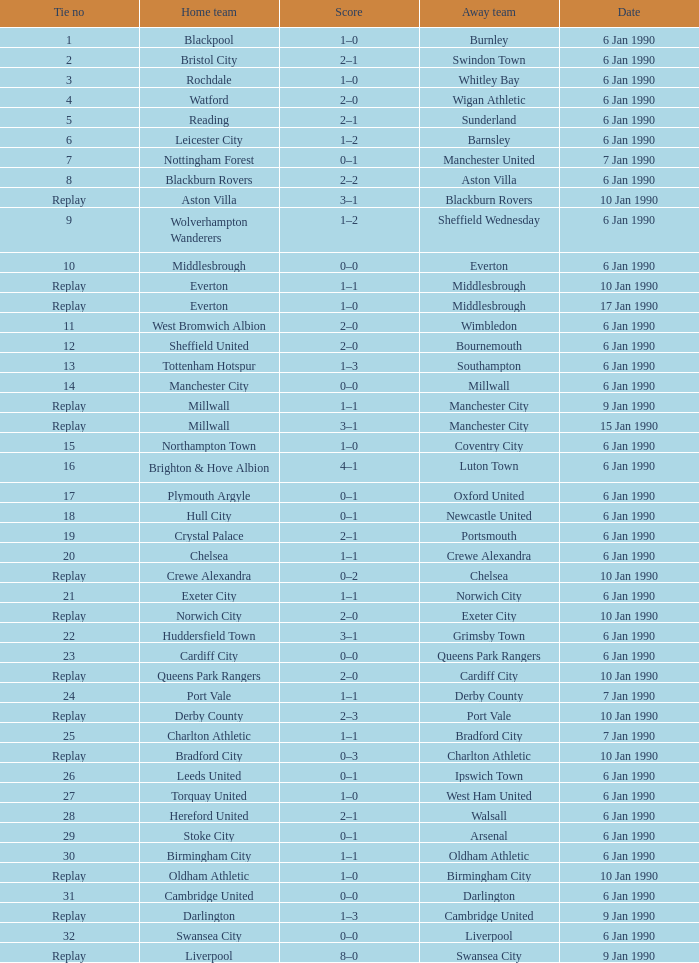Can you parse all the data within this table? {'header': ['Tie no', 'Home team', 'Score', 'Away team', 'Date'], 'rows': [['1', 'Blackpool', '1–0', 'Burnley', '6 Jan 1990'], ['2', 'Bristol City', '2–1', 'Swindon Town', '6 Jan 1990'], ['3', 'Rochdale', '1–0', 'Whitley Bay', '6 Jan 1990'], ['4', 'Watford', '2–0', 'Wigan Athletic', '6 Jan 1990'], ['5', 'Reading', '2–1', 'Sunderland', '6 Jan 1990'], ['6', 'Leicester City', '1–2', 'Barnsley', '6 Jan 1990'], ['7', 'Nottingham Forest', '0–1', 'Manchester United', '7 Jan 1990'], ['8', 'Blackburn Rovers', '2–2', 'Aston Villa', '6 Jan 1990'], ['Replay', 'Aston Villa', '3–1', 'Blackburn Rovers', '10 Jan 1990'], ['9', 'Wolverhampton Wanderers', '1–2', 'Sheffield Wednesday', '6 Jan 1990'], ['10', 'Middlesbrough', '0–0', 'Everton', '6 Jan 1990'], ['Replay', 'Everton', '1–1', 'Middlesbrough', '10 Jan 1990'], ['Replay', 'Everton', '1–0', 'Middlesbrough', '17 Jan 1990'], ['11', 'West Bromwich Albion', '2–0', 'Wimbledon', '6 Jan 1990'], ['12', 'Sheffield United', '2–0', 'Bournemouth', '6 Jan 1990'], ['13', 'Tottenham Hotspur', '1–3', 'Southampton', '6 Jan 1990'], ['14', 'Manchester City', '0–0', 'Millwall', '6 Jan 1990'], ['Replay', 'Millwall', '1–1', 'Manchester City', '9 Jan 1990'], ['Replay', 'Millwall', '3–1', 'Manchester City', '15 Jan 1990'], ['15', 'Northampton Town', '1–0', 'Coventry City', '6 Jan 1990'], ['16', 'Brighton & Hove Albion', '4–1', 'Luton Town', '6 Jan 1990'], ['17', 'Plymouth Argyle', '0–1', 'Oxford United', '6 Jan 1990'], ['18', 'Hull City', '0–1', 'Newcastle United', '6 Jan 1990'], ['19', 'Crystal Palace', '2–1', 'Portsmouth', '6 Jan 1990'], ['20', 'Chelsea', '1–1', 'Crewe Alexandra', '6 Jan 1990'], ['Replay', 'Crewe Alexandra', '0–2', 'Chelsea', '10 Jan 1990'], ['21', 'Exeter City', '1–1', 'Norwich City', '6 Jan 1990'], ['Replay', 'Norwich City', '2–0', 'Exeter City', '10 Jan 1990'], ['22', 'Huddersfield Town', '3–1', 'Grimsby Town', '6 Jan 1990'], ['23', 'Cardiff City', '0–0', 'Queens Park Rangers', '6 Jan 1990'], ['Replay', 'Queens Park Rangers', '2–0', 'Cardiff City', '10 Jan 1990'], ['24', 'Port Vale', '1–1', 'Derby County', '7 Jan 1990'], ['Replay', 'Derby County', '2–3', 'Port Vale', '10 Jan 1990'], ['25', 'Charlton Athletic', '1–1', 'Bradford City', '7 Jan 1990'], ['Replay', 'Bradford City', '0–3', 'Charlton Athletic', '10 Jan 1990'], ['26', 'Leeds United', '0–1', 'Ipswich Town', '6 Jan 1990'], ['27', 'Torquay United', '1–0', 'West Ham United', '6 Jan 1990'], ['28', 'Hereford United', '2–1', 'Walsall', '6 Jan 1990'], ['29', 'Stoke City', '0–1', 'Arsenal', '6 Jan 1990'], ['30', 'Birmingham City', '1–1', 'Oldham Athletic', '6 Jan 1990'], ['Replay', 'Oldham Athletic', '1–0', 'Birmingham City', '10 Jan 1990'], ['31', 'Cambridge United', '0–0', 'Darlington', '6 Jan 1990'], ['Replay', 'Darlington', '1–3', 'Cambridge United', '9 Jan 1990'], ['32', 'Swansea City', '0–0', 'Liverpool', '6 Jan 1990'], ['Replay', 'Liverpool', '8–0', 'Swansea City', '9 Jan 1990']]} What date did home team liverpool play? 9 Jan 1990. 